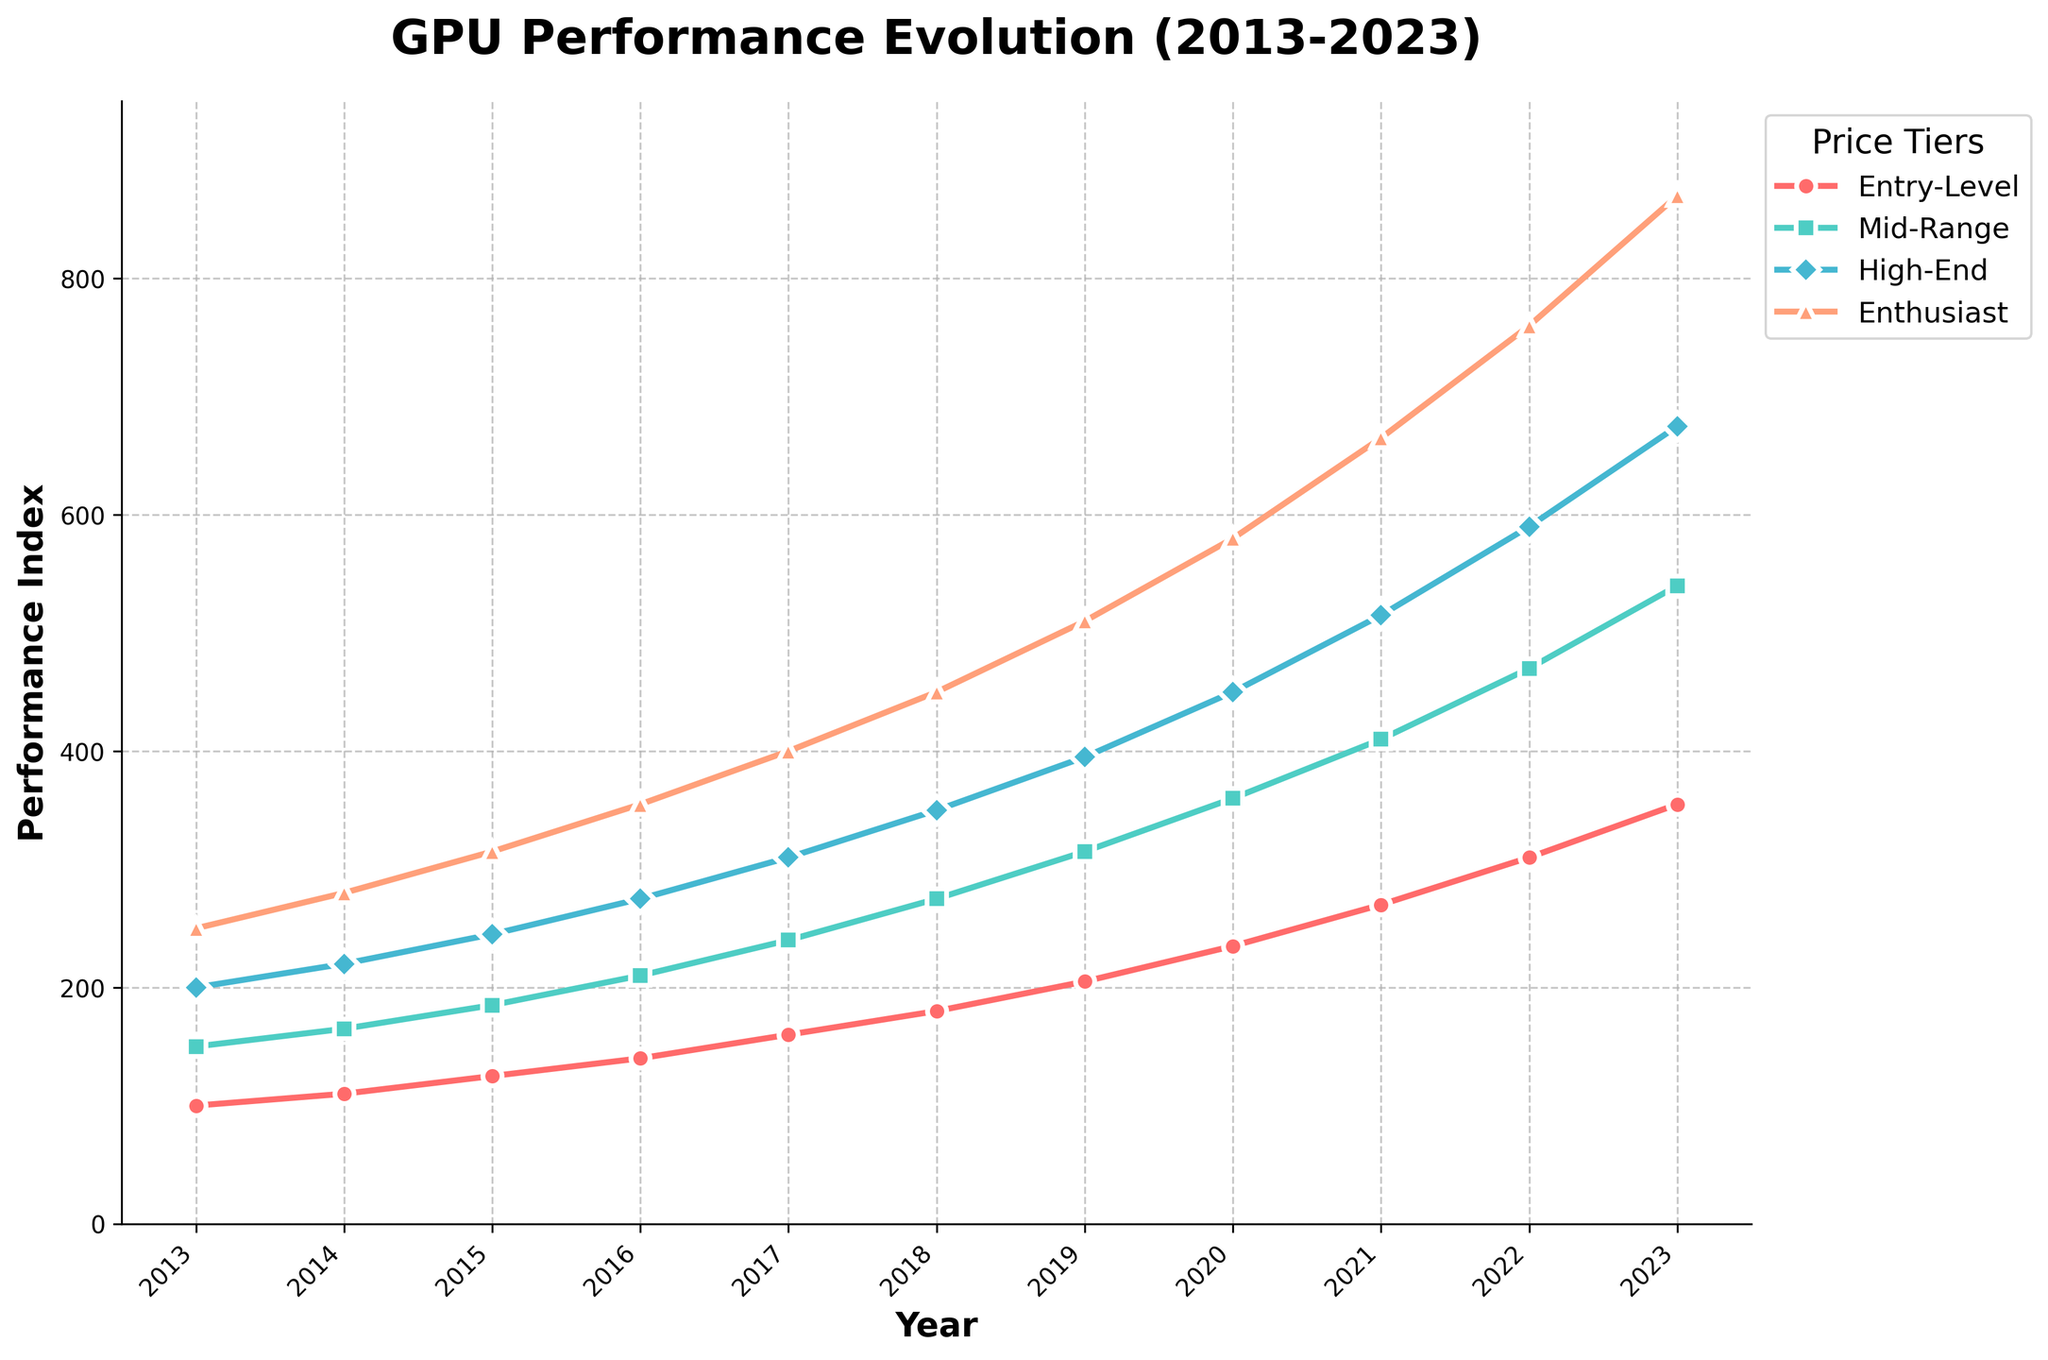Which price tier has shown the most consistent growth over the decade? To determine consistency, we need to check how steadily each tier has grown. The Entry-Level tier, for example, starts at 100 in 2013 and grows to 355 in 2023, showing steady increments each year. By visually comparing the line slopes and stability, it's clear that the Entry-Level and Mid-Range tiers have smooth, consistent inclines.
Answer: Entry-Level and Mid-Range What is the difference in performance between the Entry-Level and High-End tiers in 2023? In 2023, the performance index for the Entry-Level tier is 355, and for the High-End tier, it is 675. The difference is calculated as 675 - 355.
Answer: 320 Among all the tiers, which one exhibits the steepest incline in performance between 2016 and 2020? To identify the steepest incline, we need to compare the performance index increment for each tier between 2016 and 2020. For Entry-Level: (235-140), Mid-Range: (360-210), High-End: (450-275), Enthusiast: (580-355). The Enthusiast tier shows the largest growth increment of 225.
Answer: Enthusiast Which year shows the highest performance increase in the High-End tier compared to the previous year? To find this, we need to look at the year-over-year increases: 2014 (220-200), 2015 (245-220), 2016 (275-245), 2017 (310-275), 2018 (350-310), 2019 (395-350), 2020 (450-395), 2021 (515-450), 2022 (590-515), 2023 (675-590). The highest increase is from 2020 to 2021, with a value of 65.
Answer: 2021 What is the average performance increase per year for the Mid-Range tier over the decade? The start performance in 2013 is 150, and the end performance in 2023 is 540. The total increase is 540 - 150. To get the average increase per year, divide this number by the number of years (10).
Answer: 39 Which tier has the widest spread in performance from 2013 to 2023? The spread refers to the difference between the highest and lowest values over the period. Calculate the difference for each tier: Entry-Level (355-100), Mid-Range (540-150), High-End (675-200), Enthusiast (870-250). The Enthusiast tier has the widest spread with a difference of 870 - 250.
Answer: Enthusiast If we combined the performance indices of Entry-Level and Mid-Range tiers in 2019, what would be the total? In 2019, the Entry-Level performance index is 205, and the Mid-Range performance index is 315. Adding these gives 205 + 315.
Answer: 520 Which tier had the sharpest decline in growth rate between 2022 and 2023? Calculating the year-over-year increase from 2022 to 2023 for each tier: Entry-Level (355-310), Mid-Range (540-470), High-End (675-590), Enthusiast (870-760). The smallest increase, indicating the sharpest decline in growth rate, is for the High-End tier with an increase of 675 - 590.
Answer: High-End 